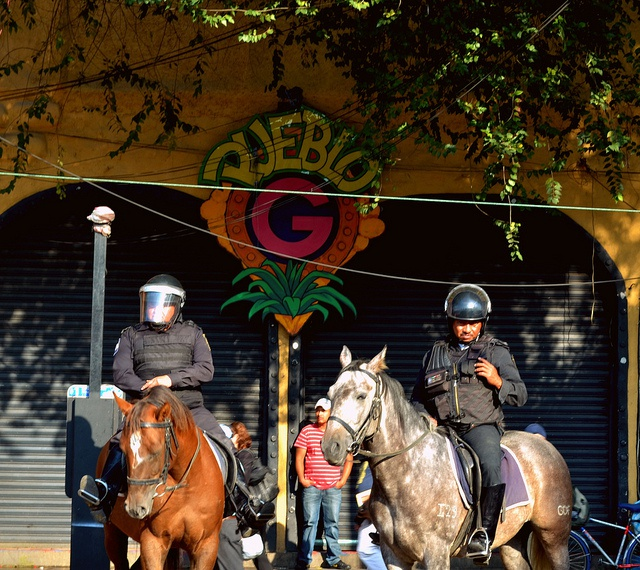Describe the objects in this image and their specific colors. I can see horse in black, white, and tan tones, horse in black, brown, red, orange, and maroon tones, people in black, gray, and maroon tones, people in black, gray, and white tones, and people in black, salmon, gray, and white tones in this image. 